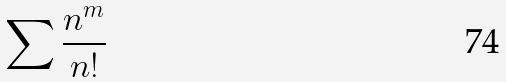<formula> <loc_0><loc_0><loc_500><loc_500>\sum \frac { n ^ { m } } { n ! }</formula> 